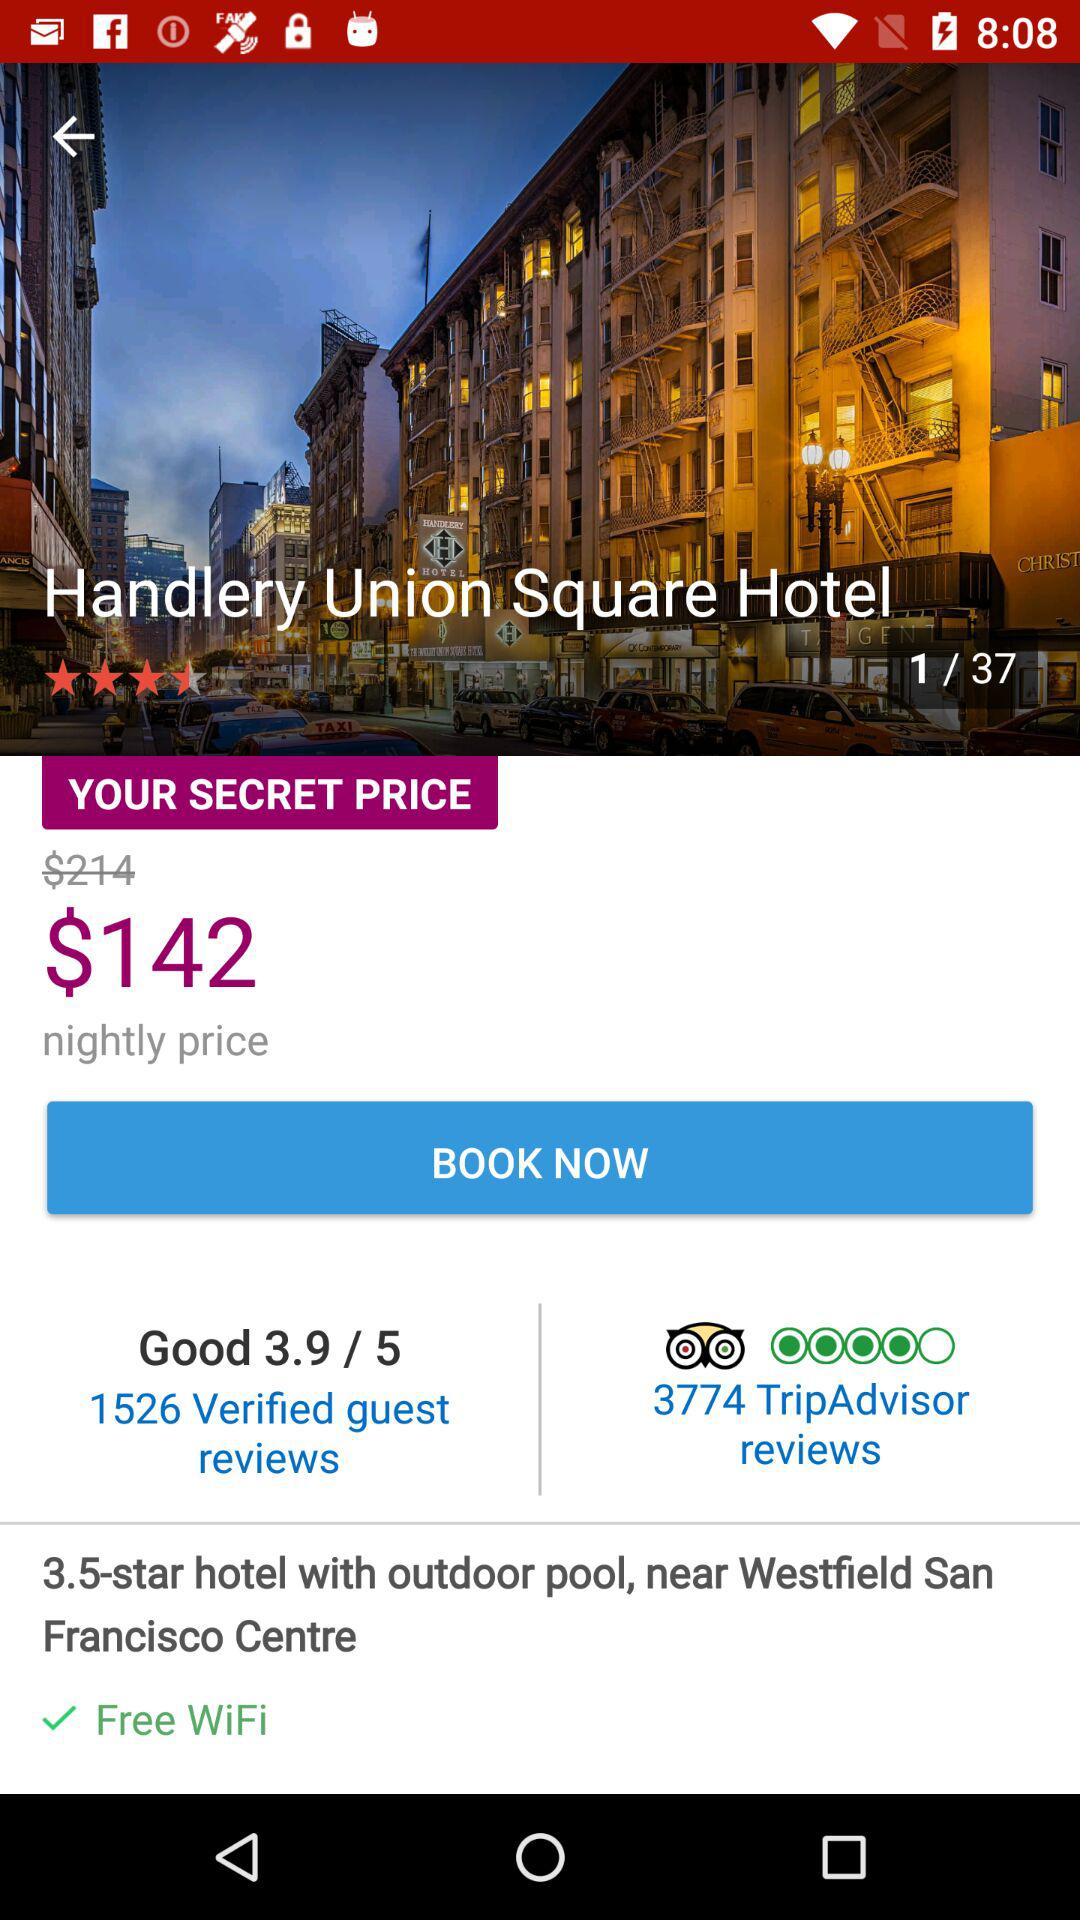Which image are we on? You are on image 1. 